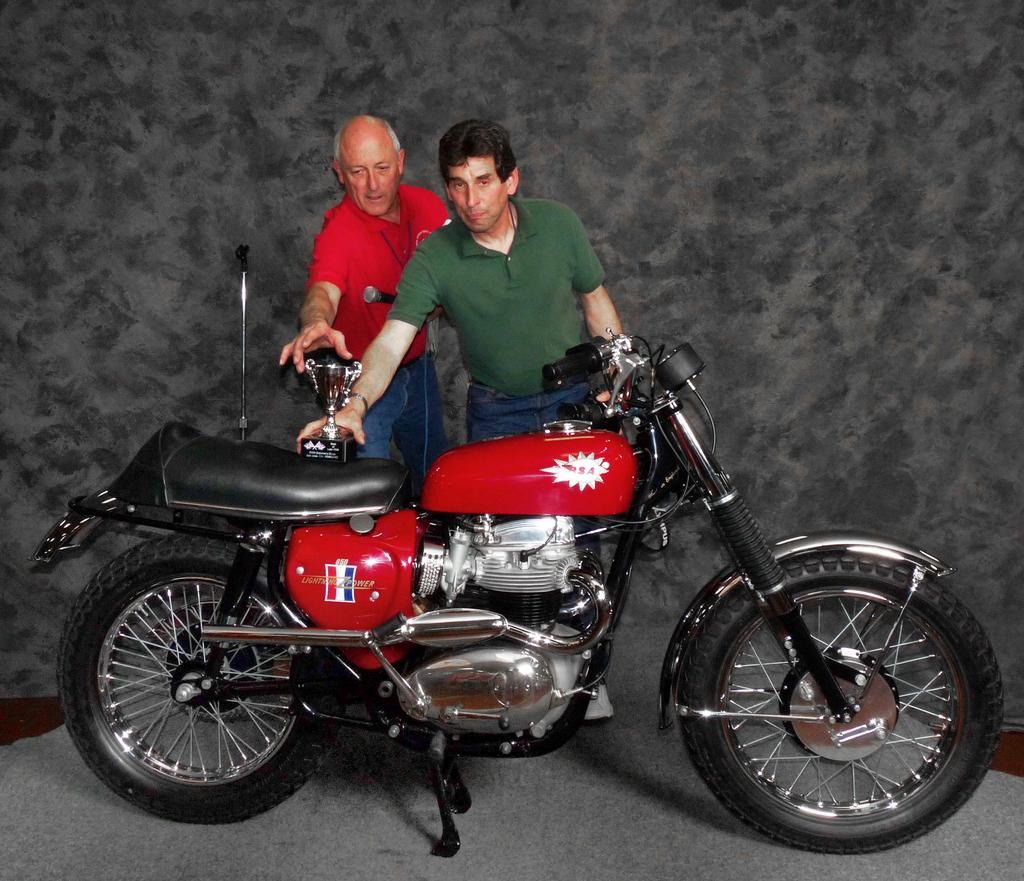How would you summarize this image in a sentence or two? In this picture, in the middle, we can see two men are standing in front of the bike. On the bike, we can see a shield. In the background, we can also see black color. 